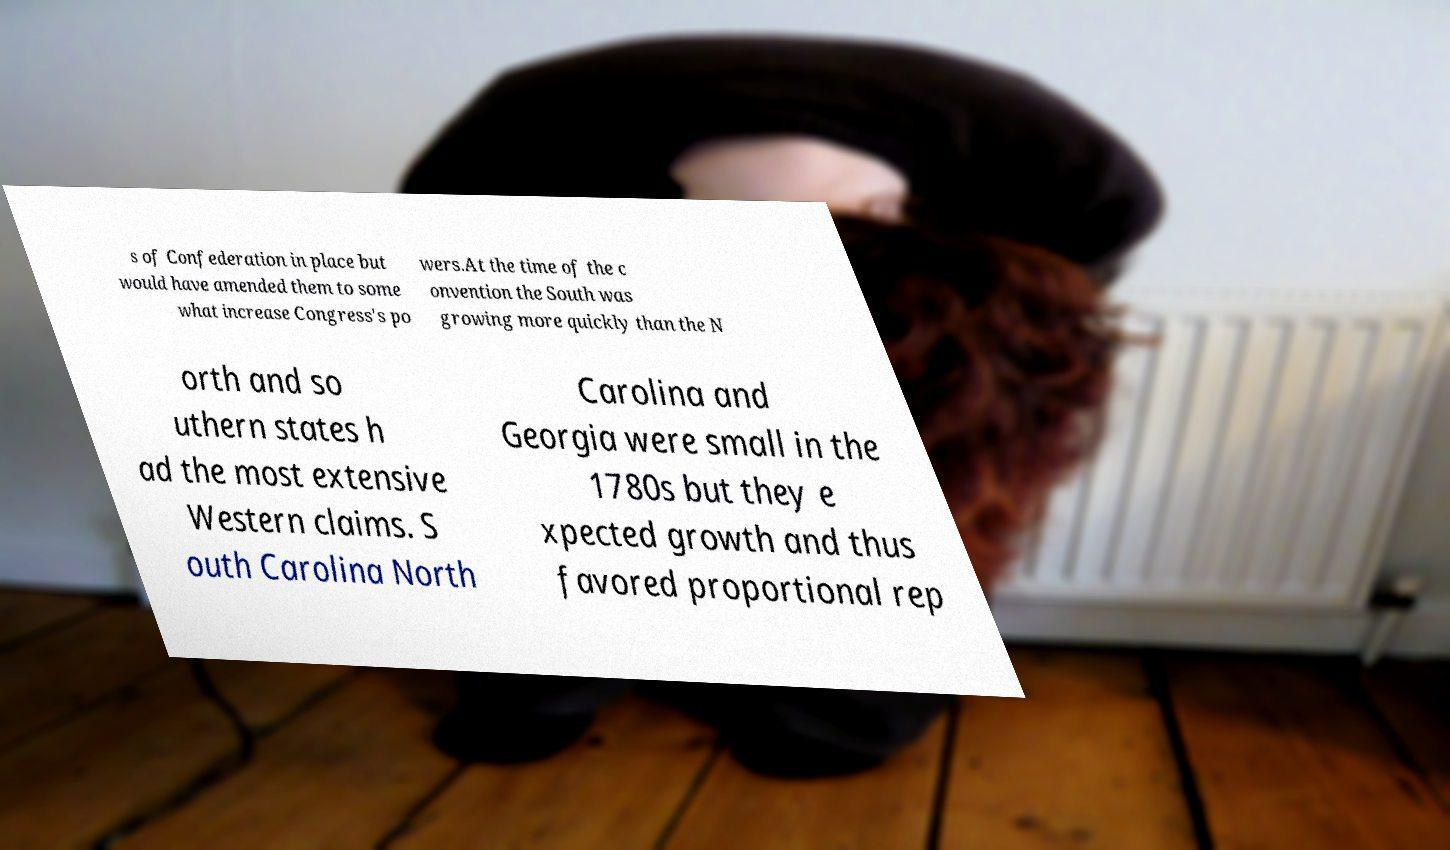What messages or text are displayed in this image? I need them in a readable, typed format. s of Confederation in place but would have amended them to some what increase Congress's po wers.At the time of the c onvention the South was growing more quickly than the N orth and so uthern states h ad the most extensive Western claims. S outh Carolina North Carolina and Georgia were small in the 1780s but they e xpected growth and thus favored proportional rep 